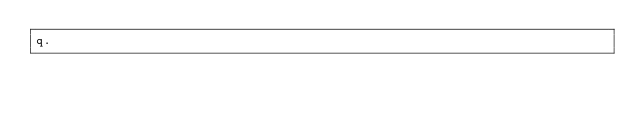Convert code to text. <code><loc_0><loc_0><loc_500><loc_500><_JavaScript_>q.
</code> 